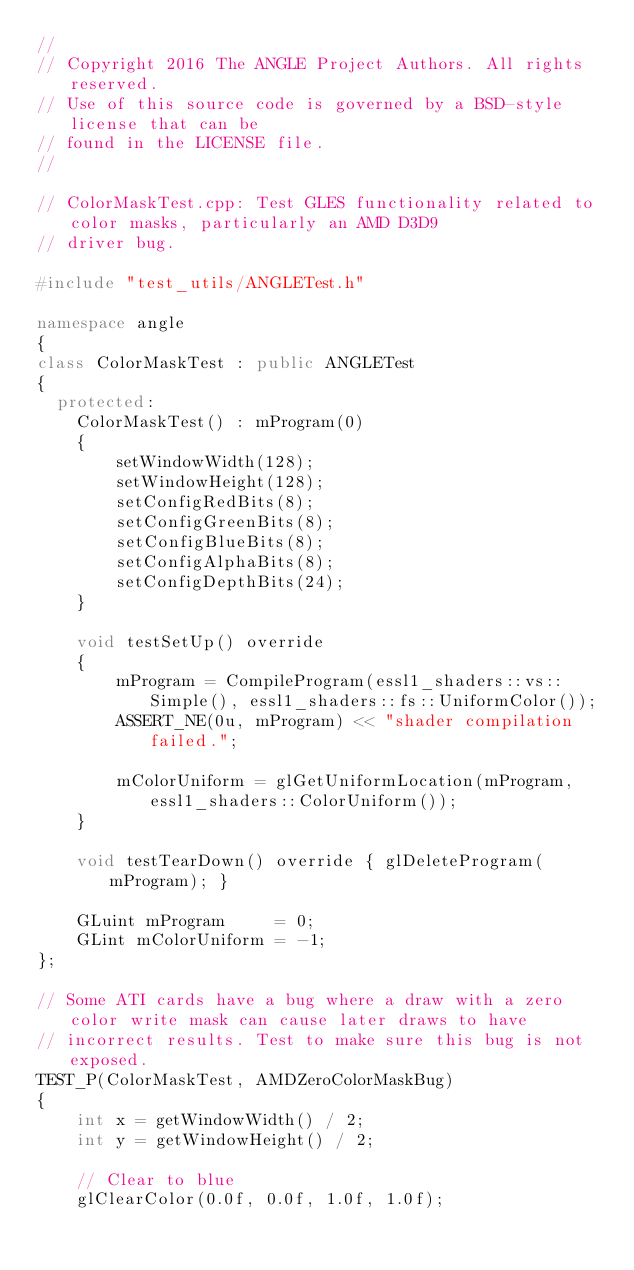Convert code to text. <code><loc_0><loc_0><loc_500><loc_500><_C++_>//
// Copyright 2016 The ANGLE Project Authors. All rights reserved.
// Use of this source code is governed by a BSD-style license that can be
// found in the LICENSE file.
//

// ColorMaskTest.cpp: Test GLES functionality related to color masks, particularly an AMD D3D9
// driver bug.

#include "test_utils/ANGLETest.h"

namespace angle
{
class ColorMaskTest : public ANGLETest
{
  protected:
    ColorMaskTest() : mProgram(0)
    {
        setWindowWidth(128);
        setWindowHeight(128);
        setConfigRedBits(8);
        setConfigGreenBits(8);
        setConfigBlueBits(8);
        setConfigAlphaBits(8);
        setConfigDepthBits(24);
    }

    void testSetUp() override
    {
        mProgram = CompileProgram(essl1_shaders::vs::Simple(), essl1_shaders::fs::UniformColor());
        ASSERT_NE(0u, mProgram) << "shader compilation failed.";

        mColorUniform = glGetUniformLocation(mProgram, essl1_shaders::ColorUniform());
    }

    void testTearDown() override { glDeleteProgram(mProgram); }

    GLuint mProgram     = 0;
    GLint mColorUniform = -1;
};

// Some ATI cards have a bug where a draw with a zero color write mask can cause later draws to have
// incorrect results. Test to make sure this bug is not exposed.
TEST_P(ColorMaskTest, AMDZeroColorMaskBug)
{
    int x = getWindowWidth() / 2;
    int y = getWindowHeight() / 2;

    // Clear to blue
    glClearColor(0.0f, 0.0f, 1.0f, 1.0f);</code> 